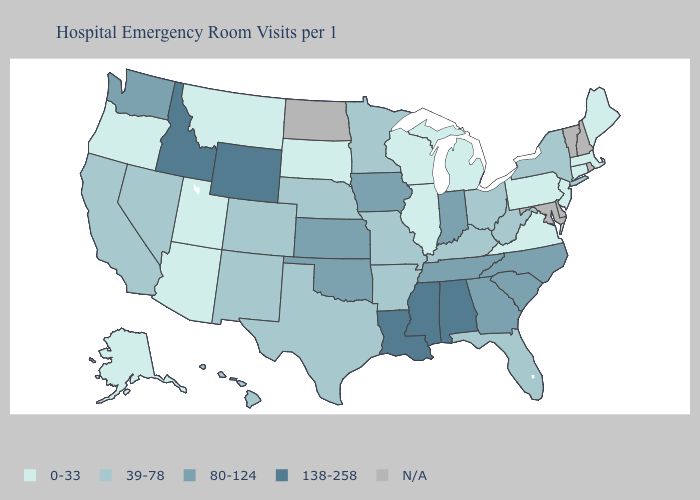What is the lowest value in the USA?
Write a very short answer. 0-33. Does the first symbol in the legend represent the smallest category?
Answer briefly. Yes. Is the legend a continuous bar?
Give a very brief answer. No. Among the states that border New Jersey , which have the lowest value?
Give a very brief answer. Pennsylvania. What is the value of New Mexico?
Answer briefly. 39-78. Name the states that have a value in the range N/A?
Short answer required. Delaware, Maryland, New Hampshire, North Dakota, Rhode Island, Vermont. Does Kansas have the highest value in the MidWest?
Concise answer only. Yes. Is the legend a continuous bar?
Give a very brief answer. No. Which states have the lowest value in the MidWest?
Keep it brief. Illinois, Michigan, South Dakota, Wisconsin. Name the states that have a value in the range N/A?
Concise answer only. Delaware, Maryland, New Hampshire, North Dakota, Rhode Island, Vermont. What is the value of Iowa?
Write a very short answer. 80-124. What is the value of New Jersey?
Quick response, please. 0-33. Does the map have missing data?
Concise answer only. Yes. Does Pennsylvania have the lowest value in the USA?
Write a very short answer. Yes. 